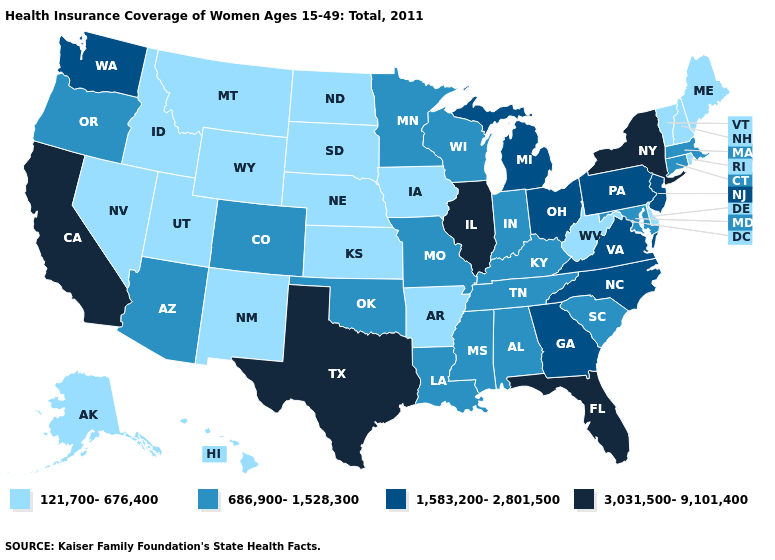Does the map have missing data?
Keep it brief. No. What is the highest value in states that border Kentucky?
Answer briefly. 3,031,500-9,101,400. Is the legend a continuous bar?
Write a very short answer. No. Name the states that have a value in the range 121,700-676,400?
Quick response, please. Alaska, Arkansas, Delaware, Hawaii, Idaho, Iowa, Kansas, Maine, Montana, Nebraska, Nevada, New Hampshire, New Mexico, North Dakota, Rhode Island, South Dakota, Utah, Vermont, West Virginia, Wyoming. Does New Mexico have the highest value in the West?
Short answer required. No. Name the states that have a value in the range 686,900-1,528,300?
Quick response, please. Alabama, Arizona, Colorado, Connecticut, Indiana, Kentucky, Louisiana, Maryland, Massachusetts, Minnesota, Mississippi, Missouri, Oklahoma, Oregon, South Carolina, Tennessee, Wisconsin. Does Wyoming have the lowest value in the USA?
Concise answer only. Yes. Name the states that have a value in the range 121,700-676,400?
Concise answer only. Alaska, Arkansas, Delaware, Hawaii, Idaho, Iowa, Kansas, Maine, Montana, Nebraska, Nevada, New Hampshire, New Mexico, North Dakota, Rhode Island, South Dakota, Utah, Vermont, West Virginia, Wyoming. What is the value of Mississippi?
Answer briefly. 686,900-1,528,300. What is the value of West Virginia?
Be succinct. 121,700-676,400. Does Arkansas have the lowest value in the South?
Short answer required. Yes. Among the states that border New York , which have the highest value?
Write a very short answer. New Jersey, Pennsylvania. Name the states that have a value in the range 686,900-1,528,300?
Concise answer only. Alabama, Arizona, Colorado, Connecticut, Indiana, Kentucky, Louisiana, Maryland, Massachusetts, Minnesota, Mississippi, Missouri, Oklahoma, Oregon, South Carolina, Tennessee, Wisconsin. Name the states that have a value in the range 686,900-1,528,300?
Give a very brief answer. Alabama, Arizona, Colorado, Connecticut, Indiana, Kentucky, Louisiana, Maryland, Massachusetts, Minnesota, Mississippi, Missouri, Oklahoma, Oregon, South Carolina, Tennessee, Wisconsin. 